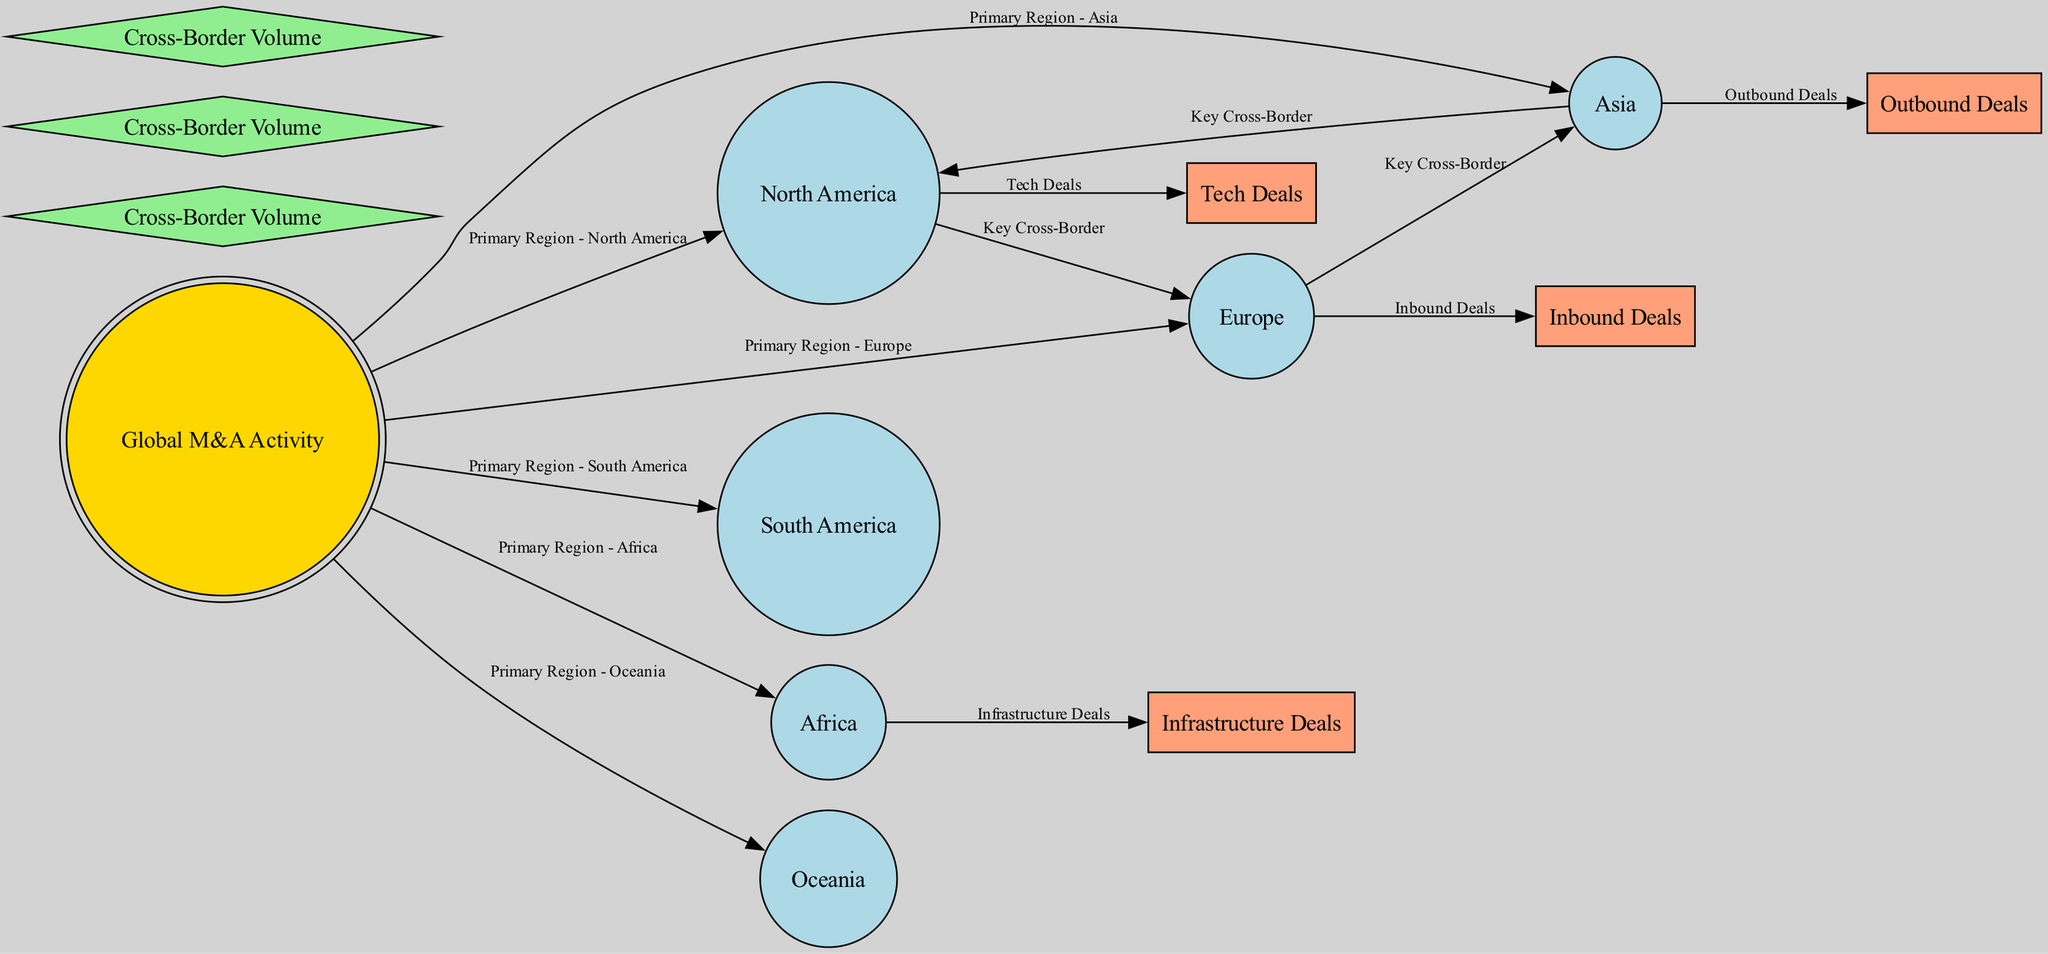What is the central node in the diagram? The central node represents the overall theme of the diagram and is labeled "Global M&A Activity." It is visually emphasized as the main focal point of the diagram.
Answer: Global M&A Activity How many regions are represented in the diagram? By counting the nodes classified as "region," we identify six regions: North America, Europe, Asia, South America, Africa, and Oceania. This total gives us the count of distinct regions displayed.
Answer: 6 What type of edge connects North America to Europe? The edge connecting these two nodes is labeled "Key Cross-Border," indicating it represents a significant transaction type between these regions. This relationship is visually apparent in the diagram structure.
Answer: Key Cross-Border Which region is associated with "Infrastructure Deals"? By looking at the edges connected from the central node and analyzing the labels, we see that "Infrastructure Deals" is linked to Africa, specifying this region's involvement in that type of deal.
Answer: Africa Which region has "Outbound Deals"? The "Outbound Deals" label is connected to the "Asia" node within the diagram, indicating that this region is characterized by outbound transactions specifically.
Answer: Asia How many types of deals are shown in the diagram? The diagram includes four types of deals: Inbound Deals, Outbound Deals, Infrastructure Deals, and Tech Deals. By identifying distinct labels and categorizing them, we ascertain this total.
Answer: 4 Which region is associated with "Tech Deals"? The diagram shows that "Tech Deals" is linked to the North America region, clearly illustrated by the edge that connects them. This connection identifies North America as the region for this type of deal.
Answer: North America What is the relationship between Europe and Asia in this diagram? The relationship between Europe and Asia is represented by the edge labeled "Key Cross-Border." This indicates there is a significant transaction flow seen between these two regions.
Answer: Key Cross-Border 